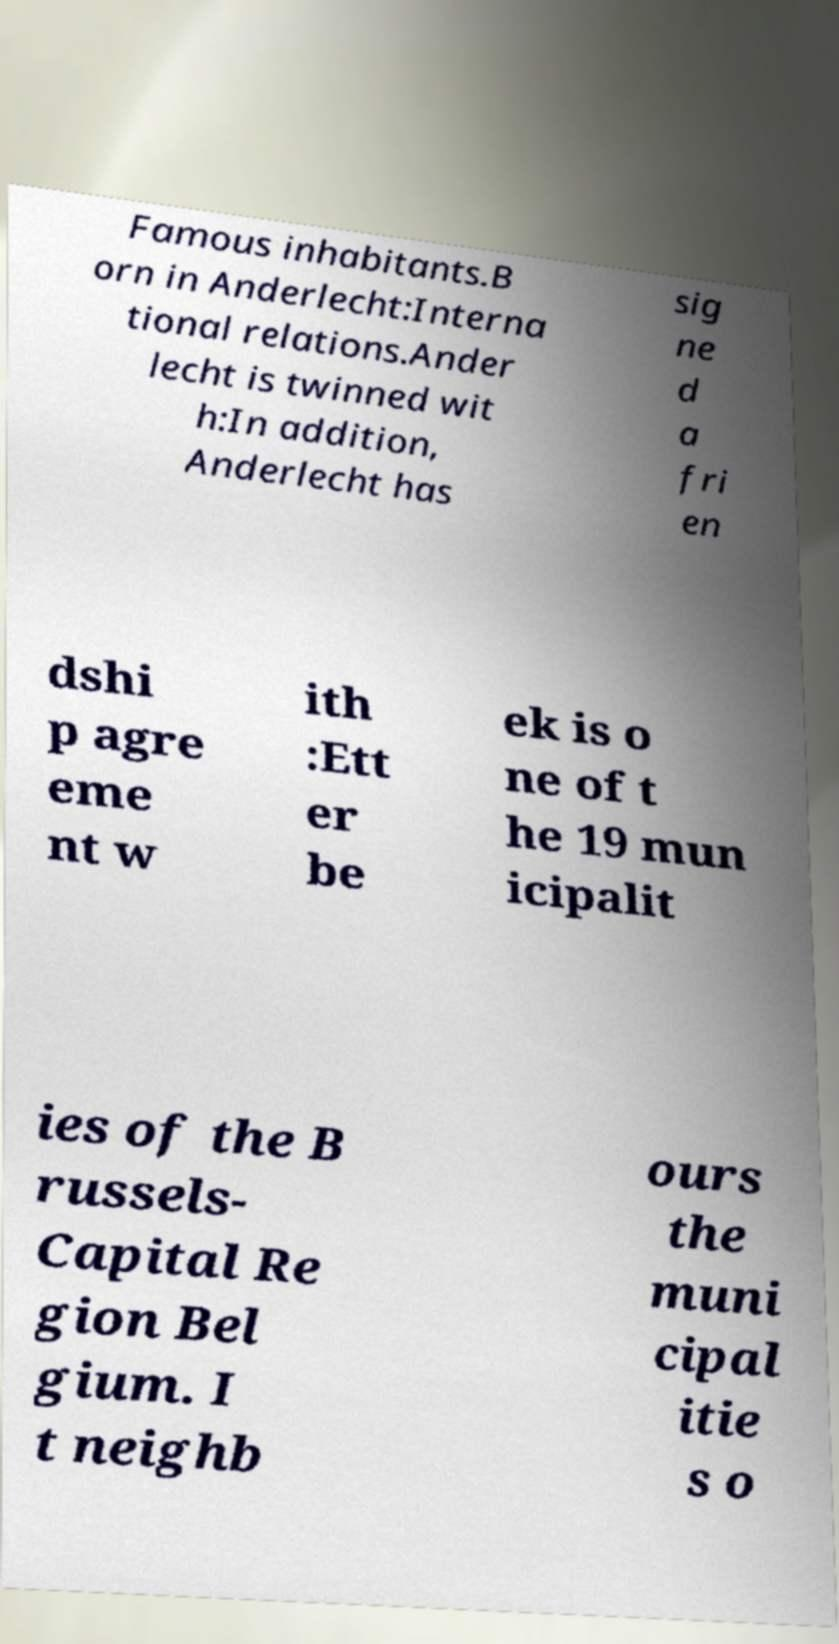There's text embedded in this image that I need extracted. Can you transcribe it verbatim? Famous inhabitants.B orn in Anderlecht:Interna tional relations.Ander lecht is twinned wit h:In addition, Anderlecht has sig ne d a fri en dshi p agre eme nt w ith :Ett er be ek is o ne of t he 19 mun icipalit ies of the B russels- Capital Re gion Bel gium. I t neighb ours the muni cipal itie s o 